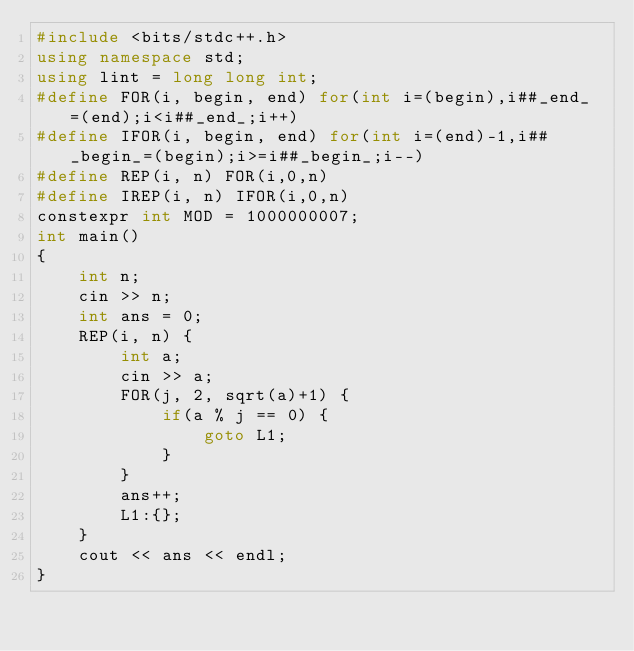<code> <loc_0><loc_0><loc_500><loc_500><_C++_>#include <bits/stdc++.h>
using namespace std;
using lint = long long int;
#define FOR(i, begin, end) for(int i=(begin),i##_end_=(end);i<i##_end_;i++)
#define IFOR(i, begin, end) for(int i=(end)-1,i##_begin_=(begin);i>=i##_begin_;i--)
#define REP(i, n) FOR(i,0,n)
#define IREP(i, n) IFOR(i,0,n)
constexpr int MOD = 1000000007;
int main()
{
    int n;
    cin >> n;
    int ans = 0;
    REP(i, n) {
        int a;
        cin >> a;
        FOR(j, 2, sqrt(a)+1) {
            if(a % j == 0) {
                goto L1;
            }
        }
        ans++;
        L1:{};
    }
    cout << ans << endl;
}
</code> 